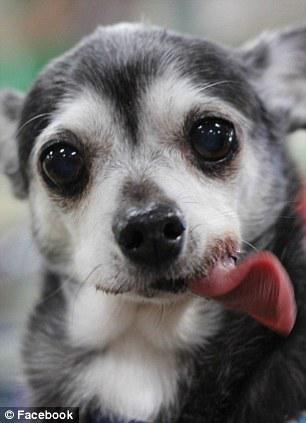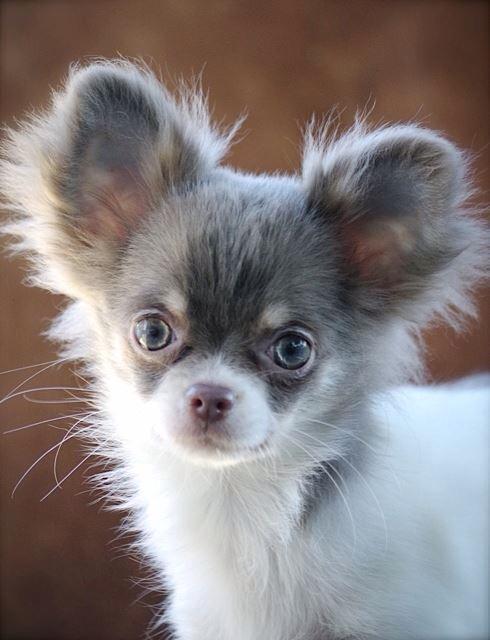The first image is the image on the left, the second image is the image on the right. Evaluate the accuracy of this statement regarding the images: "One of the images shows a dog with its tongue sticking out.". Is it true? Answer yes or no. Yes. The first image is the image on the left, the second image is the image on the right. Analyze the images presented: Is the assertion "Two little dogs have eyes wide open, but only one of them is showing his tongue." valid? Answer yes or no. Yes. The first image is the image on the left, the second image is the image on the right. Considering the images on both sides, is "An image shows a dog with its tongue sticking out." valid? Answer yes or no. Yes. The first image is the image on the left, the second image is the image on the right. For the images shown, is this caption "One of the dogs has its tongue sticking out." true? Answer yes or no. Yes. 